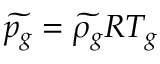Convert formula to latex. <formula><loc_0><loc_0><loc_500><loc_500>\widetilde { p _ { g } } = \widetilde { \rho _ { g } } R T _ { g }</formula> 